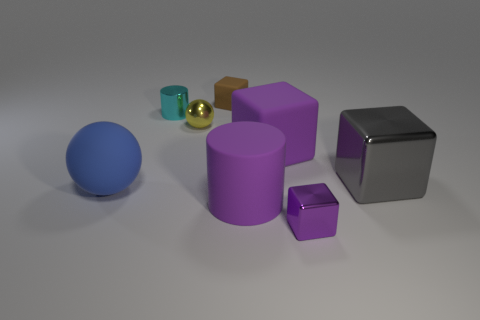Add 1 rubber cubes. How many objects exist? 9 Subtract all cylinders. How many objects are left? 6 Subtract all large metallic blocks. Subtract all tiny brown matte things. How many objects are left? 6 Add 2 blue matte things. How many blue matte things are left? 3 Add 1 small yellow balls. How many small yellow balls exist? 2 Subtract 0 blue cubes. How many objects are left? 8 